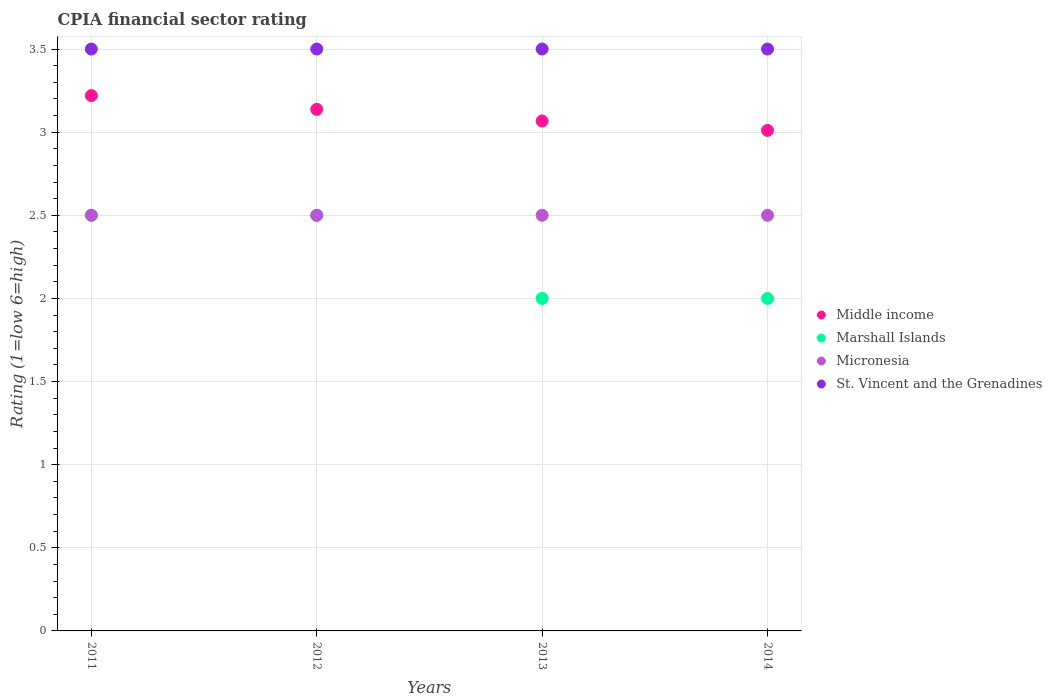How many different coloured dotlines are there?
Your answer should be compact. 4. Is the number of dotlines equal to the number of legend labels?
Your answer should be compact. Yes. What is the CPIA rating in Middle income in 2013?
Provide a succinct answer. 3.07. Across all years, what is the minimum CPIA rating in Middle income?
Your answer should be very brief. 3.01. In which year was the CPIA rating in St. Vincent and the Grenadines maximum?
Your answer should be compact. 2011. What is the total CPIA rating in Micronesia in the graph?
Provide a succinct answer. 10. What is the average CPIA rating in St. Vincent and the Grenadines per year?
Your response must be concise. 3.5. In the year 2011, what is the difference between the CPIA rating in Micronesia and CPIA rating in Marshall Islands?
Provide a short and direct response. 0. What is the ratio of the CPIA rating in Middle income in 2013 to that in 2014?
Ensure brevity in your answer.  1.02. Is the CPIA rating in Micronesia in 2012 less than that in 2014?
Ensure brevity in your answer.  No. Is the difference between the CPIA rating in Micronesia in 2012 and 2013 greater than the difference between the CPIA rating in Marshall Islands in 2012 and 2013?
Your answer should be compact. No. What is the difference between the highest and the lowest CPIA rating in Micronesia?
Make the answer very short. 0. In how many years, is the CPIA rating in Marshall Islands greater than the average CPIA rating in Marshall Islands taken over all years?
Offer a very short reply. 2. Is it the case that in every year, the sum of the CPIA rating in Micronesia and CPIA rating in Marshall Islands  is greater than the sum of CPIA rating in Middle income and CPIA rating in St. Vincent and the Grenadines?
Provide a succinct answer. No. Is it the case that in every year, the sum of the CPIA rating in St. Vincent and the Grenadines and CPIA rating in Middle income  is greater than the CPIA rating in Marshall Islands?
Provide a succinct answer. Yes. Is the CPIA rating in Marshall Islands strictly less than the CPIA rating in St. Vincent and the Grenadines over the years?
Your response must be concise. Yes. Does the graph contain any zero values?
Your answer should be very brief. No. How many legend labels are there?
Keep it short and to the point. 4. How are the legend labels stacked?
Provide a short and direct response. Vertical. What is the title of the graph?
Ensure brevity in your answer.  CPIA financial sector rating. Does "Eritrea" appear as one of the legend labels in the graph?
Provide a short and direct response. No. What is the label or title of the X-axis?
Ensure brevity in your answer.  Years. What is the label or title of the Y-axis?
Your answer should be very brief. Rating (1=low 6=high). What is the Rating (1=low 6=high) in Middle income in 2011?
Provide a short and direct response. 3.22. What is the Rating (1=low 6=high) in Marshall Islands in 2011?
Your answer should be very brief. 2.5. What is the Rating (1=low 6=high) of Middle income in 2012?
Make the answer very short. 3.14. What is the Rating (1=low 6=high) of Marshall Islands in 2012?
Your answer should be very brief. 2.5. What is the Rating (1=low 6=high) of Micronesia in 2012?
Your answer should be very brief. 2.5. What is the Rating (1=low 6=high) in St. Vincent and the Grenadines in 2012?
Your answer should be compact. 3.5. What is the Rating (1=low 6=high) in Middle income in 2013?
Provide a short and direct response. 3.07. What is the Rating (1=low 6=high) in Marshall Islands in 2013?
Provide a succinct answer. 2. What is the Rating (1=low 6=high) in Middle income in 2014?
Provide a succinct answer. 3.01. What is the Rating (1=low 6=high) in St. Vincent and the Grenadines in 2014?
Offer a very short reply. 3.5. Across all years, what is the maximum Rating (1=low 6=high) of Middle income?
Offer a terse response. 3.22. Across all years, what is the maximum Rating (1=low 6=high) of Marshall Islands?
Ensure brevity in your answer.  2.5. Across all years, what is the minimum Rating (1=low 6=high) in Middle income?
Ensure brevity in your answer.  3.01. Across all years, what is the minimum Rating (1=low 6=high) of Marshall Islands?
Keep it short and to the point. 2. What is the total Rating (1=low 6=high) in Middle income in the graph?
Provide a succinct answer. 12.44. What is the total Rating (1=low 6=high) of Micronesia in the graph?
Keep it short and to the point. 10. What is the total Rating (1=low 6=high) of St. Vincent and the Grenadines in the graph?
Provide a succinct answer. 14. What is the difference between the Rating (1=low 6=high) of Middle income in 2011 and that in 2012?
Your answer should be compact. 0.08. What is the difference between the Rating (1=low 6=high) in Marshall Islands in 2011 and that in 2012?
Ensure brevity in your answer.  0. What is the difference between the Rating (1=low 6=high) in Middle income in 2011 and that in 2013?
Provide a short and direct response. 0.15. What is the difference between the Rating (1=low 6=high) of Micronesia in 2011 and that in 2013?
Your response must be concise. 0. What is the difference between the Rating (1=low 6=high) in Middle income in 2011 and that in 2014?
Provide a short and direct response. 0.21. What is the difference between the Rating (1=low 6=high) of Middle income in 2012 and that in 2013?
Your response must be concise. 0.07. What is the difference between the Rating (1=low 6=high) of Middle income in 2012 and that in 2014?
Offer a terse response. 0.13. What is the difference between the Rating (1=low 6=high) of Marshall Islands in 2012 and that in 2014?
Provide a short and direct response. 0.5. What is the difference between the Rating (1=low 6=high) in St. Vincent and the Grenadines in 2012 and that in 2014?
Your response must be concise. 0. What is the difference between the Rating (1=low 6=high) of Middle income in 2013 and that in 2014?
Provide a short and direct response. 0.06. What is the difference between the Rating (1=low 6=high) of Micronesia in 2013 and that in 2014?
Provide a succinct answer. 0. What is the difference between the Rating (1=low 6=high) of St. Vincent and the Grenadines in 2013 and that in 2014?
Ensure brevity in your answer.  0. What is the difference between the Rating (1=low 6=high) in Middle income in 2011 and the Rating (1=low 6=high) in Marshall Islands in 2012?
Make the answer very short. 0.72. What is the difference between the Rating (1=low 6=high) in Middle income in 2011 and the Rating (1=low 6=high) in Micronesia in 2012?
Give a very brief answer. 0.72. What is the difference between the Rating (1=low 6=high) of Middle income in 2011 and the Rating (1=low 6=high) of St. Vincent and the Grenadines in 2012?
Provide a succinct answer. -0.28. What is the difference between the Rating (1=low 6=high) of Marshall Islands in 2011 and the Rating (1=low 6=high) of St. Vincent and the Grenadines in 2012?
Provide a succinct answer. -1. What is the difference between the Rating (1=low 6=high) in Micronesia in 2011 and the Rating (1=low 6=high) in St. Vincent and the Grenadines in 2012?
Make the answer very short. -1. What is the difference between the Rating (1=low 6=high) in Middle income in 2011 and the Rating (1=low 6=high) in Marshall Islands in 2013?
Provide a short and direct response. 1.22. What is the difference between the Rating (1=low 6=high) of Middle income in 2011 and the Rating (1=low 6=high) of Micronesia in 2013?
Your answer should be compact. 0.72. What is the difference between the Rating (1=low 6=high) of Middle income in 2011 and the Rating (1=low 6=high) of St. Vincent and the Grenadines in 2013?
Provide a succinct answer. -0.28. What is the difference between the Rating (1=low 6=high) in Marshall Islands in 2011 and the Rating (1=low 6=high) in St. Vincent and the Grenadines in 2013?
Keep it short and to the point. -1. What is the difference between the Rating (1=low 6=high) in Middle income in 2011 and the Rating (1=low 6=high) in Marshall Islands in 2014?
Provide a short and direct response. 1.22. What is the difference between the Rating (1=low 6=high) in Middle income in 2011 and the Rating (1=low 6=high) in Micronesia in 2014?
Keep it short and to the point. 0.72. What is the difference between the Rating (1=low 6=high) of Middle income in 2011 and the Rating (1=low 6=high) of St. Vincent and the Grenadines in 2014?
Offer a very short reply. -0.28. What is the difference between the Rating (1=low 6=high) in Marshall Islands in 2011 and the Rating (1=low 6=high) in Micronesia in 2014?
Your answer should be very brief. 0. What is the difference between the Rating (1=low 6=high) of Middle income in 2012 and the Rating (1=low 6=high) of Marshall Islands in 2013?
Ensure brevity in your answer.  1.14. What is the difference between the Rating (1=low 6=high) of Middle income in 2012 and the Rating (1=low 6=high) of Micronesia in 2013?
Your answer should be very brief. 0.64. What is the difference between the Rating (1=low 6=high) of Middle income in 2012 and the Rating (1=low 6=high) of St. Vincent and the Grenadines in 2013?
Your answer should be very brief. -0.36. What is the difference between the Rating (1=low 6=high) of Marshall Islands in 2012 and the Rating (1=low 6=high) of St. Vincent and the Grenadines in 2013?
Give a very brief answer. -1. What is the difference between the Rating (1=low 6=high) of Micronesia in 2012 and the Rating (1=low 6=high) of St. Vincent and the Grenadines in 2013?
Keep it short and to the point. -1. What is the difference between the Rating (1=low 6=high) in Middle income in 2012 and the Rating (1=low 6=high) in Marshall Islands in 2014?
Your answer should be compact. 1.14. What is the difference between the Rating (1=low 6=high) of Middle income in 2012 and the Rating (1=low 6=high) of Micronesia in 2014?
Offer a very short reply. 0.64. What is the difference between the Rating (1=low 6=high) in Middle income in 2012 and the Rating (1=low 6=high) in St. Vincent and the Grenadines in 2014?
Offer a terse response. -0.36. What is the difference between the Rating (1=low 6=high) in Marshall Islands in 2012 and the Rating (1=low 6=high) in Micronesia in 2014?
Give a very brief answer. 0. What is the difference between the Rating (1=low 6=high) in Micronesia in 2012 and the Rating (1=low 6=high) in St. Vincent and the Grenadines in 2014?
Your response must be concise. -1. What is the difference between the Rating (1=low 6=high) in Middle income in 2013 and the Rating (1=low 6=high) in Marshall Islands in 2014?
Your answer should be very brief. 1.07. What is the difference between the Rating (1=low 6=high) of Middle income in 2013 and the Rating (1=low 6=high) of Micronesia in 2014?
Offer a very short reply. 0.57. What is the difference between the Rating (1=low 6=high) of Middle income in 2013 and the Rating (1=low 6=high) of St. Vincent and the Grenadines in 2014?
Give a very brief answer. -0.43. What is the difference between the Rating (1=low 6=high) in Marshall Islands in 2013 and the Rating (1=low 6=high) in Micronesia in 2014?
Your answer should be compact. -0.5. What is the difference between the Rating (1=low 6=high) of Marshall Islands in 2013 and the Rating (1=low 6=high) of St. Vincent and the Grenadines in 2014?
Make the answer very short. -1.5. What is the difference between the Rating (1=low 6=high) of Micronesia in 2013 and the Rating (1=low 6=high) of St. Vincent and the Grenadines in 2014?
Keep it short and to the point. -1. What is the average Rating (1=low 6=high) of Middle income per year?
Your answer should be compact. 3.11. What is the average Rating (1=low 6=high) of Marshall Islands per year?
Your response must be concise. 2.25. What is the average Rating (1=low 6=high) in St. Vincent and the Grenadines per year?
Ensure brevity in your answer.  3.5. In the year 2011, what is the difference between the Rating (1=low 6=high) in Middle income and Rating (1=low 6=high) in Marshall Islands?
Your answer should be compact. 0.72. In the year 2011, what is the difference between the Rating (1=low 6=high) in Middle income and Rating (1=low 6=high) in Micronesia?
Your answer should be compact. 0.72. In the year 2011, what is the difference between the Rating (1=low 6=high) of Middle income and Rating (1=low 6=high) of St. Vincent and the Grenadines?
Provide a short and direct response. -0.28. In the year 2011, what is the difference between the Rating (1=low 6=high) of Marshall Islands and Rating (1=low 6=high) of Micronesia?
Offer a terse response. 0. In the year 2011, what is the difference between the Rating (1=low 6=high) in Micronesia and Rating (1=low 6=high) in St. Vincent and the Grenadines?
Your answer should be compact. -1. In the year 2012, what is the difference between the Rating (1=low 6=high) in Middle income and Rating (1=low 6=high) in Marshall Islands?
Provide a short and direct response. 0.64. In the year 2012, what is the difference between the Rating (1=low 6=high) in Middle income and Rating (1=low 6=high) in Micronesia?
Make the answer very short. 0.64. In the year 2012, what is the difference between the Rating (1=low 6=high) in Middle income and Rating (1=low 6=high) in St. Vincent and the Grenadines?
Provide a short and direct response. -0.36. In the year 2012, what is the difference between the Rating (1=low 6=high) in Marshall Islands and Rating (1=low 6=high) in Micronesia?
Make the answer very short. 0. In the year 2012, what is the difference between the Rating (1=low 6=high) in Marshall Islands and Rating (1=low 6=high) in St. Vincent and the Grenadines?
Ensure brevity in your answer.  -1. In the year 2012, what is the difference between the Rating (1=low 6=high) in Micronesia and Rating (1=low 6=high) in St. Vincent and the Grenadines?
Your response must be concise. -1. In the year 2013, what is the difference between the Rating (1=low 6=high) of Middle income and Rating (1=low 6=high) of Marshall Islands?
Offer a very short reply. 1.07. In the year 2013, what is the difference between the Rating (1=low 6=high) of Middle income and Rating (1=low 6=high) of Micronesia?
Offer a very short reply. 0.57. In the year 2013, what is the difference between the Rating (1=low 6=high) in Middle income and Rating (1=low 6=high) in St. Vincent and the Grenadines?
Make the answer very short. -0.43. In the year 2013, what is the difference between the Rating (1=low 6=high) of Marshall Islands and Rating (1=low 6=high) of St. Vincent and the Grenadines?
Provide a succinct answer. -1.5. In the year 2014, what is the difference between the Rating (1=low 6=high) in Middle income and Rating (1=low 6=high) in Marshall Islands?
Provide a succinct answer. 1.01. In the year 2014, what is the difference between the Rating (1=low 6=high) of Middle income and Rating (1=low 6=high) of Micronesia?
Your answer should be compact. 0.51. In the year 2014, what is the difference between the Rating (1=low 6=high) of Middle income and Rating (1=low 6=high) of St. Vincent and the Grenadines?
Your response must be concise. -0.49. In the year 2014, what is the difference between the Rating (1=low 6=high) in Marshall Islands and Rating (1=low 6=high) in Micronesia?
Provide a succinct answer. -0.5. In the year 2014, what is the difference between the Rating (1=low 6=high) in Micronesia and Rating (1=low 6=high) in St. Vincent and the Grenadines?
Give a very brief answer. -1. What is the ratio of the Rating (1=low 6=high) in Middle income in 2011 to that in 2012?
Give a very brief answer. 1.03. What is the ratio of the Rating (1=low 6=high) of Marshall Islands in 2011 to that in 2012?
Ensure brevity in your answer.  1. What is the ratio of the Rating (1=low 6=high) of St. Vincent and the Grenadines in 2011 to that in 2012?
Give a very brief answer. 1. What is the ratio of the Rating (1=low 6=high) in Middle income in 2011 to that in 2013?
Provide a succinct answer. 1.05. What is the ratio of the Rating (1=low 6=high) of Marshall Islands in 2011 to that in 2013?
Offer a terse response. 1.25. What is the ratio of the Rating (1=low 6=high) of St. Vincent and the Grenadines in 2011 to that in 2013?
Your answer should be very brief. 1. What is the ratio of the Rating (1=low 6=high) of Middle income in 2011 to that in 2014?
Ensure brevity in your answer.  1.07. What is the ratio of the Rating (1=low 6=high) of Marshall Islands in 2011 to that in 2014?
Your response must be concise. 1.25. What is the ratio of the Rating (1=low 6=high) of Micronesia in 2011 to that in 2014?
Your response must be concise. 1. What is the ratio of the Rating (1=low 6=high) in St. Vincent and the Grenadines in 2011 to that in 2014?
Your answer should be very brief. 1. What is the ratio of the Rating (1=low 6=high) in Middle income in 2012 to that in 2013?
Your answer should be compact. 1.02. What is the ratio of the Rating (1=low 6=high) of Marshall Islands in 2012 to that in 2013?
Provide a succinct answer. 1.25. What is the ratio of the Rating (1=low 6=high) in Micronesia in 2012 to that in 2013?
Provide a short and direct response. 1. What is the ratio of the Rating (1=low 6=high) in St. Vincent and the Grenadines in 2012 to that in 2013?
Make the answer very short. 1. What is the ratio of the Rating (1=low 6=high) in Middle income in 2012 to that in 2014?
Keep it short and to the point. 1.04. What is the ratio of the Rating (1=low 6=high) of Marshall Islands in 2012 to that in 2014?
Give a very brief answer. 1.25. What is the ratio of the Rating (1=low 6=high) of St. Vincent and the Grenadines in 2012 to that in 2014?
Offer a very short reply. 1. What is the ratio of the Rating (1=low 6=high) in Middle income in 2013 to that in 2014?
Your answer should be very brief. 1.02. What is the difference between the highest and the second highest Rating (1=low 6=high) of Middle income?
Keep it short and to the point. 0.08. What is the difference between the highest and the second highest Rating (1=low 6=high) of Marshall Islands?
Offer a very short reply. 0. What is the difference between the highest and the lowest Rating (1=low 6=high) of Middle income?
Your answer should be compact. 0.21. What is the difference between the highest and the lowest Rating (1=low 6=high) in Marshall Islands?
Your response must be concise. 0.5. 